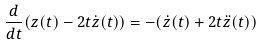Convert formula to latex. <formula><loc_0><loc_0><loc_500><loc_500>\frac { d } { d t } ( z ( t ) - 2 t \dot { z } ( t ) ) = - ( \dot { z } ( t ) + 2 t \ddot { z } ( t ) )</formula> 